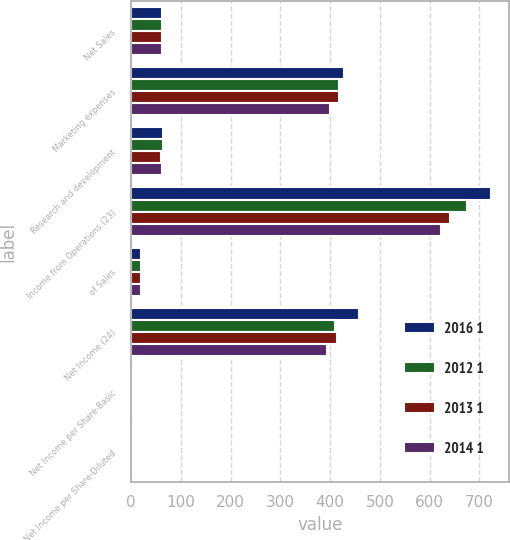Convert chart. <chart><loc_0><loc_0><loc_500><loc_500><stacked_bar_chart><ecel><fcel>Net Sales<fcel>Marketing expenses<fcel>Research and development<fcel>Income from Operations (23)<fcel>of Sales<fcel>Net Income (24)<fcel>Net Income per Share-Basic<fcel>Net Income per Share-Diluted<nl><fcel>2016 1<fcel>62.5<fcel>427.2<fcel>63.2<fcel>724.2<fcel>20.7<fcel>459<fcel>1.78<fcel>1.75<nl><fcel>2012 1<fcel>62.5<fcel>417.5<fcel>64.7<fcel>674.2<fcel>19.9<fcel>410.4<fcel>1.57<fcel>1.54<nl><fcel>2013 1<fcel>62.5<fcel>416.9<fcel>59.8<fcel>641.2<fcel>19.4<fcel>413.9<fcel>1.53<fcel>1.51<nl><fcel>2014 1<fcel>62.5<fcel>399.8<fcel>61.8<fcel>622.2<fcel>19.5<fcel>394.4<fcel>1.43<fcel>1.4<nl></chart> 